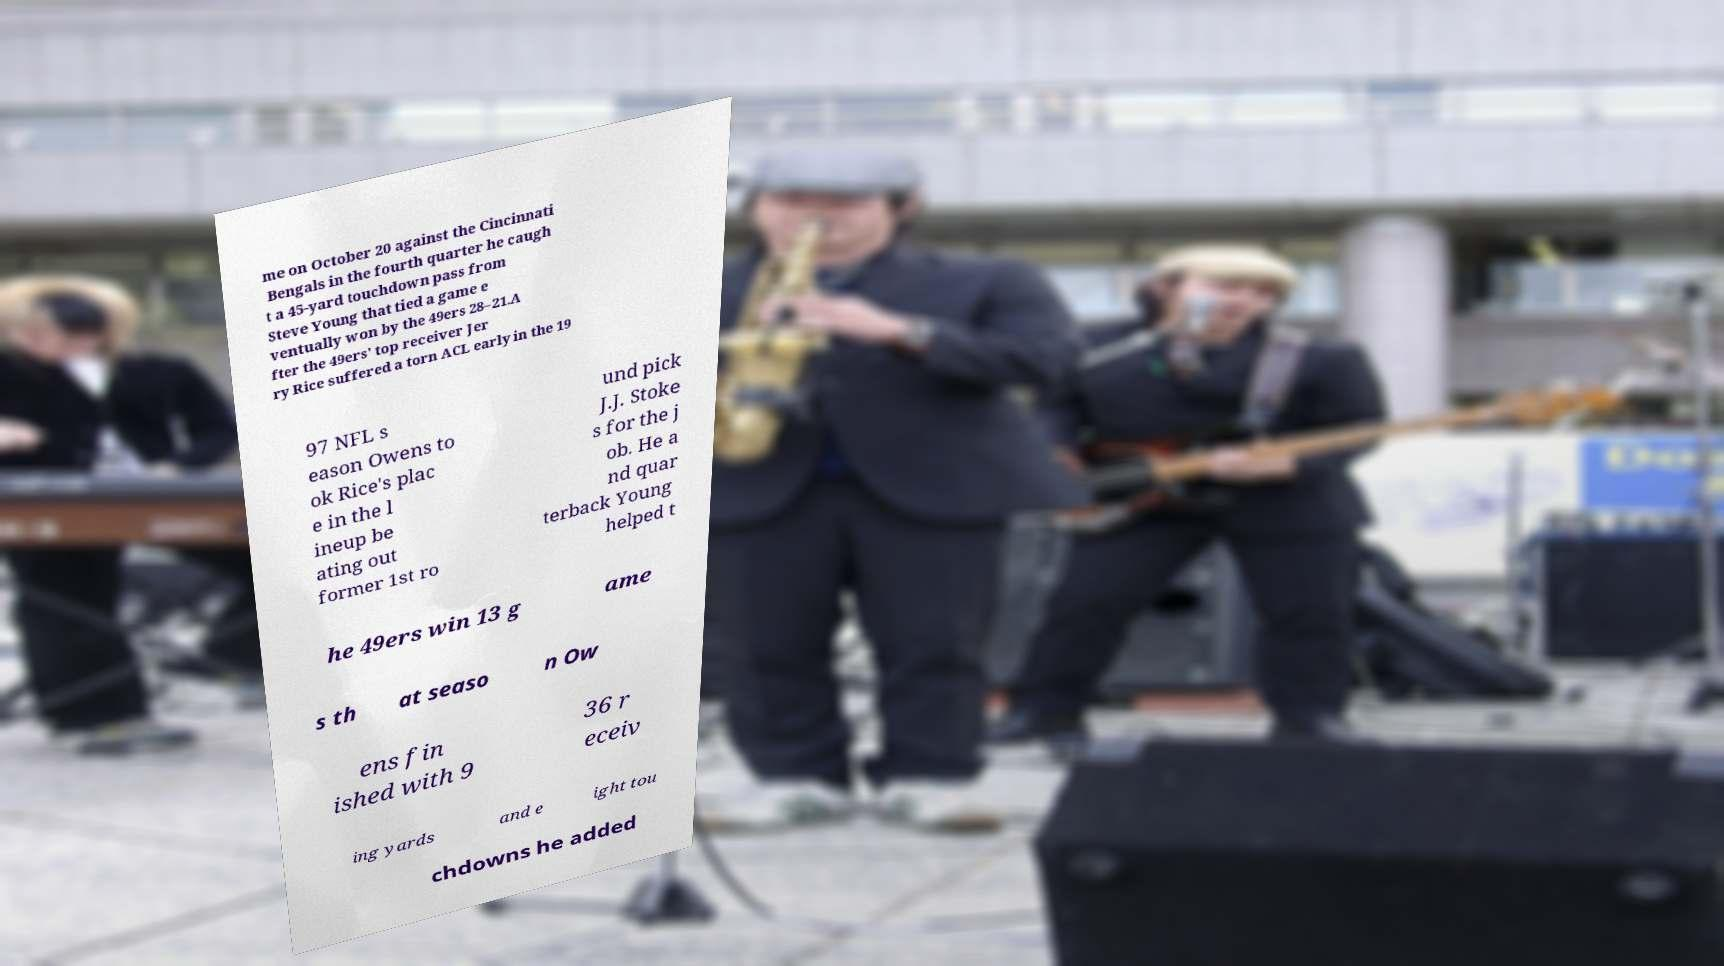Can you read and provide the text displayed in the image?This photo seems to have some interesting text. Can you extract and type it out for me? me on October 20 against the Cincinnati Bengals in the fourth quarter he caugh t a 45-yard touchdown pass from Steve Young that tied a game e ventually won by the 49ers 28–21.A fter the 49ers' top receiver Jer ry Rice suffered a torn ACL early in the 19 97 NFL s eason Owens to ok Rice's plac e in the l ineup be ating out former 1st ro und pick J.J. Stoke s for the j ob. He a nd quar terback Young helped t he 49ers win 13 g ame s th at seaso n Ow ens fin ished with 9 36 r eceiv ing yards and e ight tou chdowns he added 